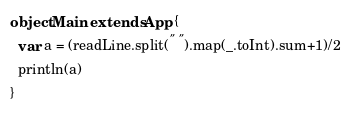<code> <loc_0><loc_0><loc_500><loc_500><_Scala_>object Main extends App {
  var a = (readLine.split(" ").map(_.toInt).sum+1)/2
  println(a)
}</code> 